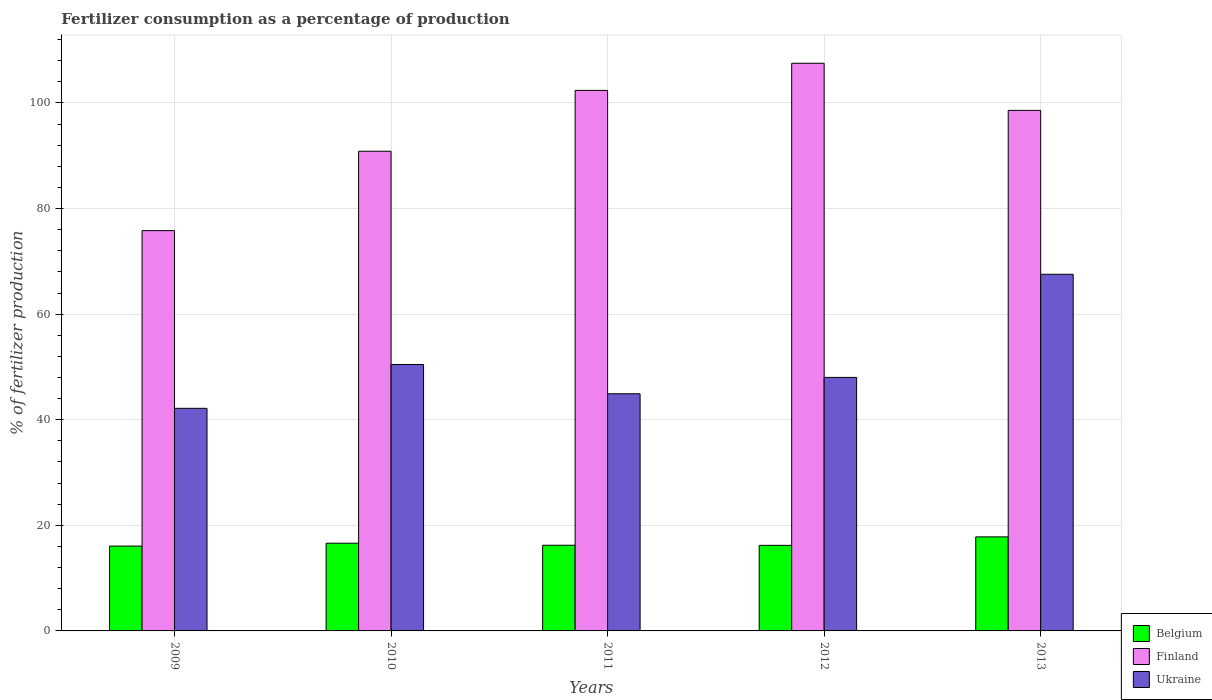Are the number of bars per tick equal to the number of legend labels?
Offer a terse response. Yes. Are the number of bars on each tick of the X-axis equal?
Offer a very short reply. Yes. How many bars are there on the 5th tick from the right?
Your response must be concise. 3. What is the label of the 4th group of bars from the left?
Your answer should be compact. 2012. What is the percentage of fertilizers consumed in Belgium in 2009?
Your answer should be very brief. 16.07. Across all years, what is the maximum percentage of fertilizers consumed in Belgium?
Make the answer very short. 17.81. Across all years, what is the minimum percentage of fertilizers consumed in Belgium?
Give a very brief answer. 16.07. In which year was the percentage of fertilizers consumed in Finland maximum?
Your response must be concise. 2012. In which year was the percentage of fertilizers consumed in Ukraine minimum?
Keep it short and to the point. 2009. What is the total percentage of fertilizers consumed in Belgium in the graph?
Your answer should be compact. 82.93. What is the difference between the percentage of fertilizers consumed in Ukraine in 2009 and that in 2012?
Offer a very short reply. -5.86. What is the difference between the percentage of fertilizers consumed in Belgium in 2011 and the percentage of fertilizers consumed in Finland in 2012?
Your answer should be very brief. -91.29. What is the average percentage of fertilizers consumed in Ukraine per year?
Your answer should be very brief. 50.62. In the year 2012, what is the difference between the percentage of fertilizers consumed in Finland and percentage of fertilizers consumed in Belgium?
Give a very brief answer. 91.31. What is the ratio of the percentage of fertilizers consumed in Finland in 2010 to that in 2012?
Offer a very short reply. 0.85. What is the difference between the highest and the second highest percentage of fertilizers consumed in Ukraine?
Your answer should be compact. 17.09. What is the difference between the highest and the lowest percentage of fertilizers consumed in Belgium?
Keep it short and to the point. 1.74. In how many years, is the percentage of fertilizers consumed in Finland greater than the average percentage of fertilizers consumed in Finland taken over all years?
Offer a very short reply. 3. Is the sum of the percentage of fertilizers consumed in Ukraine in 2010 and 2011 greater than the maximum percentage of fertilizers consumed in Finland across all years?
Your answer should be very brief. No. What does the 1st bar from the left in 2012 represents?
Your answer should be compact. Belgium. Is it the case that in every year, the sum of the percentage of fertilizers consumed in Ukraine and percentage of fertilizers consumed in Belgium is greater than the percentage of fertilizers consumed in Finland?
Make the answer very short. No. How many bars are there?
Offer a terse response. 15. Are all the bars in the graph horizontal?
Make the answer very short. No. How many years are there in the graph?
Offer a very short reply. 5. Are the values on the major ticks of Y-axis written in scientific E-notation?
Offer a terse response. No. Where does the legend appear in the graph?
Provide a short and direct response. Bottom right. How many legend labels are there?
Provide a short and direct response. 3. What is the title of the graph?
Ensure brevity in your answer.  Fertilizer consumption as a percentage of production. Does "Libya" appear as one of the legend labels in the graph?
Make the answer very short. No. What is the label or title of the Y-axis?
Your answer should be very brief. % of fertilizer production. What is the % of fertilizer production of Belgium in 2009?
Keep it short and to the point. 16.07. What is the % of fertilizer production of Finland in 2009?
Your answer should be very brief. 75.82. What is the % of fertilizer production of Ukraine in 2009?
Your answer should be very brief. 42.16. What is the % of fertilizer production of Belgium in 2010?
Your answer should be compact. 16.61. What is the % of fertilizer production in Finland in 2010?
Provide a short and direct response. 90.86. What is the % of fertilizer production in Ukraine in 2010?
Make the answer very short. 50.46. What is the % of fertilizer production in Belgium in 2011?
Your response must be concise. 16.23. What is the % of fertilizer production in Finland in 2011?
Make the answer very short. 102.38. What is the % of fertilizer production of Ukraine in 2011?
Offer a very short reply. 44.92. What is the % of fertilizer production of Belgium in 2012?
Keep it short and to the point. 16.21. What is the % of fertilizer production in Finland in 2012?
Your answer should be compact. 107.52. What is the % of fertilizer production of Ukraine in 2012?
Your answer should be very brief. 48.02. What is the % of fertilizer production in Belgium in 2013?
Keep it short and to the point. 17.81. What is the % of fertilizer production of Finland in 2013?
Offer a terse response. 98.59. What is the % of fertilizer production in Ukraine in 2013?
Give a very brief answer. 67.55. Across all years, what is the maximum % of fertilizer production in Belgium?
Provide a succinct answer. 17.81. Across all years, what is the maximum % of fertilizer production of Finland?
Your answer should be very brief. 107.52. Across all years, what is the maximum % of fertilizer production in Ukraine?
Provide a short and direct response. 67.55. Across all years, what is the minimum % of fertilizer production of Belgium?
Give a very brief answer. 16.07. Across all years, what is the minimum % of fertilizer production of Finland?
Offer a very short reply. 75.82. Across all years, what is the minimum % of fertilizer production in Ukraine?
Your answer should be very brief. 42.16. What is the total % of fertilizer production of Belgium in the graph?
Offer a terse response. 82.93. What is the total % of fertilizer production in Finland in the graph?
Provide a succinct answer. 475.18. What is the total % of fertilizer production of Ukraine in the graph?
Provide a short and direct response. 253.12. What is the difference between the % of fertilizer production of Belgium in 2009 and that in 2010?
Provide a succinct answer. -0.54. What is the difference between the % of fertilizer production in Finland in 2009 and that in 2010?
Provide a succinct answer. -15.04. What is the difference between the % of fertilizer production in Ukraine in 2009 and that in 2010?
Ensure brevity in your answer.  -8.3. What is the difference between the % of fertilizer production in Belgium in 2009 and that in 2011?
Ensure brevity in your answer.  -0.16. What is the difference between the % of fertilizer production in Finland in 2009 and that in 2011?
Ensure brevity in your answer.  -26.56. What is the difference between the % of fertilizer production of Ukraine in 2009 and that in 2011?
Make the answer very short. -2.76. What is the difference between the % of fertilizer production in Belgium in 2009 and that in 2012?
Your response must be concise. -0.14. What is the difference between the % of fertilizer production in Finland in 2009 and that in 2012?
Ensure brevity in your answer.  -31.7. What is the difference between the % of fertilizer production of Ukraine in 2009 and that in 2012?
Your answer should be compact. -5.86. What is the difference between the % of fertilizer production in Belgium in 2009 and that in 2013?
Your answer should be very brief. -1.74. What is the difference between the % of fertilizer production in Finland in 2009 and that in 2013?
Offer a terse response. -22.78. What is the difference between the % of fertilizer production of Ukraine in 2009 and that in 2013?
Ensure brevity in your answer.  -25.39. What is the difference between the % of fertilizer production in Belgium in 2010 and that in 2011?
Provide a succinct answer. 0.38. What is the difference between the % of fertilizer production in Finland in 2010 and that in 2011?
Offer a terse response. -11.52. What is the difference between the % of fertilizer production in Ukraine in 2010 and that in 2011?
Give a very brief answer. 5.54. What is the difference between the % of fertilizer production of Belgium in 2010 and that in 2012?
Provide a short and direct response. 0.4. What is the difference between the % of fertilizer production in Finland in 2010 and that in 2012?
Provide a short and direct response. -16.66. What is the difference between the % of fertilizer production in Ukraine in 2010 and that in 2012?
Ensure brevity in your answer.  2.44. What is the difference between the % of fertilizer production of Belgium in 2010 and that in 2013?
Give a very brief answer. -1.2. What is the difference between the % of fertilizer production of Finland in 2010 and that in 2013?
Provide a short and direct response. -7.74. What is the difference between the % of fertilizer production of Ukraine in 2010 and that in 2013?
Give a very brief answer. -17.09. What is the difference between the % of fertilizer production in Belgium in 2011 and that in 2012?
Your answer should be compact. 0.02. What is the difference between the % of fertilizer production of Finland in 2011 and that in 2012?
Give a very brief answer. -5.14. What is the difference between the % of fertilizer production of Ukraine in 2011 and that in 2012?
Give a very brief answer. -3.1. What is the difference between the % of fertilizer production of Belgium in 2011 and that in 2013?
Your answer should be very brief. -1.58. What is the difference between the % of fertilizer production in Finland in 2011 and that in 2013?
Your answer should be very brief. 3.79. What is the difference between the % of fertilizer production in Ukraine in 2011 and that in 2013?
Provide a short and direct response. -22.63. What is the difference between the % of fertilizer production of Belgium in 2012 and that in 2013?
Your answer should be very brief. -1.6. What is the difference between the % of fertilizer production in Finland in 2012 and that in 2013?
Make the answer very short. 8.93. What is the difference between the % of fertilizer production in Ukraine in 2012 and that in 2013?
Offer a very short reply. -19.53. What is the difference between the % of fertilizer production of Belgium in 2009 and the % of fertilizer production of Finland in 2010?
Give a very brief answer. -74.79. What is the difference between the % of fertilizer production in Belgium in 2009 and the % of fertilizer production in Ukraine in 2010?
Your response must be concise. -34.39. What is the difference between the % of fertilizer production of Finland in 2009 and the % of fertilizer production of Ukraine in 2010?
Offer a terse response. 25.36. What is the difference between the % of fertilizer production in Belgium in 2009 and the % of fertilizer production in Finland in 2011?
Make the answer very short. -86.31. What is the difference between the % of fertilizer production in Belgium in 2009 and the % of fertilizer production in Ukraine in 2011?
Provide a succinct answer. -28.85. What is the difference between the % of fertilizer production in Finland in 2009 and the % of fertilizer production in Ukraine in 2011?
Your response must be concise. 30.9. What is the difference between the % of fertilizer production in Belgium in 2009 and the % of fertilizer production in Finland in 2012?
Keep it short and to the point. -91.45. What is the difference between the % of fertilizer production of Belgium in 2009 and the % of fertilizer production of Ukraine in 2012?
Your answer should be very brief. -31.95. What is the difference between the % of fertilizer production in Finland in 2009 and the % of fertilizer production in Ukraine in 2012?
Provide a short and direct response. 27.8. What is the difference between the % of fertilizer production of Belgium in 2009 and the % of fertilizer production of Finland in 2013?
Make the answer very short. -82.53. What is the difference between the % of fertilizer production in Belgium in 2009 and the % of fertilizer production in Ukraine in 2013?
Provide a short and direct response. -51.48. What is the difference between the % of fertilizer production in Finland in 2009 and the % of fertilizer production in Ukraine in 2013?
Provide a succinct answer. 8.27. What is the difference between the % of fertilizer production of Belgium in 2010 and the % of fertilizer production of Finland in 2011?
Ensure brevity in your answer.  -85.77. What is the difference between the % of fertilizer production in Belgium in 2010 and the % of fertilizer production in Ukraine in 2011?
Give a very brief answer. -28.31. What is the difference between the % of fertilizer production in Finland in 2010 and the % of fertilizer production in Ukraine in 2011?
Your response must be concise. 45.94. What is the difference between the % of fertilizer production of Belgium in 2010 and the % of fertilizer production of Finland in 2012?
Provide a succinct answer. -90.91. What is the difference between the % of fertilizer production of Belgium in 2010 and the % of fertilizer production of Ukraine in 2012?
Keep it short and to the point. -31.41. What is the difference between the % of fertilizer production in Finland in 2010 and the % of fertilizer production in Ukraine in 2012?
Offer a very short reply. 42.84. What is the difference between the % of fertilizer production in Belgium in 2010 and the % of fertilizer production in Finland in 2013?
Make the answer very short. -81.98. What is the difference between the % of fertilizer production of Belgium in 2010 and the % of fertilizer production of Ukraine in 2013?
Keep it short and to the point. -50.94. What is the difference between the % of fertilizer production of Finland in 2010 and the % of fertilizer production of Ukraine in 2013?
Offer a terse response. 23.3. What is the difference between the % of fertilizer production in Belgium in 2011 and the % of fertilizer production in Finland in 2012?
Provide a short and direct response. -91.29. What is the difference between the % of fertilizer production in Belgium in 2011 and the % of fertilizer production in Ukraine in 2012?
Your answer should be very brief. -31.79. What is the difference between the % of fertilizer production of Finland in 2011 and the % of fertilizer production of Ukraine in 2012?
Give a very brief answer. 54.36. What is the difference between the % of fertilizer production of Belgium in 2011 and the % of fertilizer production of Finland in 2013?
Keep it short and to the point. -82.37. What is the difference between the % of fertilizer production of Belgium in 2011 and the % of fertilizer production of Ukraine in 2013?
Ensure brevity in your answer.  -51.32. What is the difference between the % of fertilizer production in Finland in 2011 and the % of fertilizer production in Ukraine in 2013?
Make the answer very short. 34.83. What is the difference between the % of fertilizer production of Belgium in 2012 and the % of fertilizer production of Finland in 2013?
Your answer should be compact. -82.39. What is the difference between the % of fertilizer production of Belgium in 2012 and the % of fertilizer production of Ukraine in 2013?
Your answer should be very brief. -51.35. What is the difference between the % of fertilizer production in Finland in 2012 and the % of fertilizer production in Ukraine in 2013?
Your answer should be very brief. 39.97. What is the average % of fertilizer production in Belgium per year?
Provide a succinct answer. 16.59. What is the average % of fertilizer production in Finland per year?
Offer a terse response. 95.04. What is the average % of fertilizer production of Ukraine per year?
Ensure brevity in your answer.  50.62. In the year 2009, what is the difference between the % of fertilizer production in Belgium and % of fertilizer production in Finland?
Provide a short and direct response. -59.75. In the year 2009, what is the difference between the % of fertilizer production of Belgium and % of fertilizer production of Ukraine?
Give a very brief answer. -26.09. In the year 2009, what is the difference between the % of fertilizer production in Finland and % of fertilizer production in Ukraine?
Provide a short and direct response. 33.66. In the year 2010, what is the difference between the % of fertilizer production of Belgium and % of fertilizer production of Finland?
Your response must be concise. -74.25. In the year 2010, what is the difference between the % of fertilizer production of Belgium and % of fertilizer production of Ukraine?
Make the answer very short. -33.85. In the year 2010, what is the difference between the % of fertilizer production in Finland and % of fertilizer production in Ukraine?
Your response must be concise. 40.4. In the year 2011, what is the difference between the % of fertilizer production of Belgium and % of fertilizer production of Finland?
Provide a short and direct response. -86.15. In the year 2011, what is the difference between the % of fertilizer production in Belgium and % of fertilizer production in Ukraine?
Make the answer very short. -28.69. In the year 2011, what is the difference between the % of fertilizer production in Finland and % of fertilizer production in Ukraine?
Provide a succinct answer. 57.46. In the year 2012, what is the difference between the % of fertilizer production in Belgium and % of fertilizer production in Finland?
Your response must be concise. -91.31. In the year 2012, what is the difference between the % of fertilizer production in Belgium and % of fertilizer production in Ukraine?
Make the answer very short. -31.81. In the year 2012, what is the difference between the % of fertilizer production in Finland and % of fertilizer production in Ukraine?
Keep it short and to the point. 59.5. In the year 2013, what is the difference between the % of fertilizer production of Belgium and % of fertilizer production of Finland?
Your answer should be very brief. -80.78. In the year 2013, what is the difference between the % of fertilizer production in Belgium and % of fertilizer production in Ukraine?
Your response must be concise. -49.74. In the year 2013, what is the difference between the % of fertilizer production in Finland and % of fertilizer production in Ukraine?
Offer a terse response. 31.04. What is the ratio of the % of fertilizer production in Belgium in 2009 to that in 2010?
Ensure brevity in your answer.  0.97. What is the ratio of the % of fertilizer production in Finland in 2009 to that in 2010?
Keep it short and to the point. 0.83. What is the ratio of the % of fertilizer production of Ukraine in 2009 to that in 2010?
Make the answer very short. 0.84. What is the ratio of the % of fertilizer production in Finland in 2009 to that in 2011?
Give a very brief answer. 0.74. What is the ratio of the % of fertilizer production of Ukraine in 2009 to that in 2011?
Your answer should be compact. 0.94. What is the ratio of the % of fertilizer production of Finland in 2009 to that in 2012?
Ensure brevity in your answer.  0.71. What is the ratio of the % of fertilizer production of Ukraine in 2009 to that in 2012?
Your response must be concise. 0.88. What is the ratio of the % of fertilizer production in Belgium in 2009 to that in 2013?
Your answer should be compact. 0.9. What is the ratio of the % of fertilizer production of Finland in 2009 to that in 2013?
Offer a very short reply. 0.77. What is the ratio of the % of fertilizer production in Ukraine in 2009 to that in 2013?
Make the answer very short. 0.62. What is the ratio of the % of fertilizer production of Belgium in 2010 to that in 2011?
Give a very brief answer. 1.02. What is the ratio of the % of fertilizer production in Finland in 2010 to that in 2011?
Your response must be concise. 0.89. What is the ratio of the % of fertilizer production of Ukraine in 2010 to that in 2011?
Your answer should be compact. 1.12. What is the ratio of the % of fertilizer production of Finland in 2010 to that in 2012?
Give a very brief answer. 0.84. What is the ratio of the % of fertilizer production in Ukraine in 2010 to that in 2012?
Offer a terse response. 1.05. What is the ratio of the % of fertilizer production of Belgium in 2010 to that in 2013?
Provide a succinct answer. 0.93. What is the ratio of the % of fertilizer production of Finland in 2010 to that in 2013?
Offer a very short reply. 0.92. What is the ratio of the % of fertilizer production of Ukraine in 2010 to that in 2013?
Provide a succinct answer. 0.75. What is the ratio of the % of fertilizer production of Belgium in 2011 to that in 2012?
Provide a short and direct response. 1. What is the ratio of the % of fertilizer production of Finland in 2011 to that in 2012?
Offer a very short reply. 0.95. What is the ratio of the % of fertilizer production in Ukraine in 2011 to that in 2012?
Ensure brevity in your answer.  0.94. What is the ratio of the % of fertilizer production in Belgium in 2011 to that in 2013?
Give a very brief answer. 0.91. What is the ratio of the % of fertilizer production of Finland in 2011 to that in 2013?
Keep it short and to the point. 1.04. What is the ratio of the % of fertilizer production of Ukraine in 2011 to that in 2013?
Offer a terse response. 0.67. What is the ratio of the % of fertilizer production of Belgium in 2012 to that in 2013?
Your response must be concise. 0.91. What is the ratio of the % of fertilizer production in Finland in 2012 to that in 2013?
Offer a terse response. 1.09. What is the ratio of the % of fertilizer production of Ukraine in 2012 to that in 2013?
Offer a terse response. 0.71. What is the difference between the highest and the second highest % of fertilizer production of Belgium?
Offer a very short reply. 1.2. What is the difference between the highest and the second highest % of fertilizer production of Finland?
Provide a short and direct response. 5.14. What is the difference between the highest and the second highest % of fertilizer production in Ukraine?
Offer a terse response. 17.09. What is the difference between the highest and the lowest % of fertilizer production of Belgium?
Your answer should be compact. 1.74. What is the difference between the highest and the lowest % of fertilizer production in Finland?
Provide a short and direct response. 31.7. What is the difference between the highest and the lowest % of fertilizer production in Ukraine?
Ensure brevity in your answer.  25.39. 